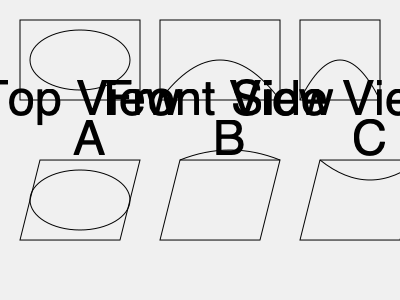Based on the given 2D projections (top, front, and side views) of a sports stadium, which of the 3D models (A, B, or C) most accurately represents the stadium's structure? To determine the correct 3D model, we need to analyze each 2D projection and compare them with the given 3D models:

1. Top View:
   - Shows an elliptical shape inside a rectangle.
   - This matches with Model A, which has an elliptical shape when viewed from above.

2. Front View:
   - Displays a curved roof structure within a rectangle.
   - This curved shape is consistent with Models B and C, but not with A.

3. Side View:
   - Shows a curved profile similar to the front view, but narrower.
   - This curved shape is consistent with Models B and C.

Analyzing the 3D models:
- Model A: Has the correct elliptical shape for the top view but lacks the curved roof structure.
- Model B: Shows a curved roof that arches upward from front to back, which doesn't match the front and side views.
- Model C: Displays a curved roof that arches downward, matching both the front and side views.

Considering all projections, Model C is the most accurate representation of the stadium. It correctly incorporates:
1. The elliptical shape visible in the top view.
2. The downward-curving roof structure seen in both front and side views.
3. The overall rectangular base visible in all views.
Answer: C 